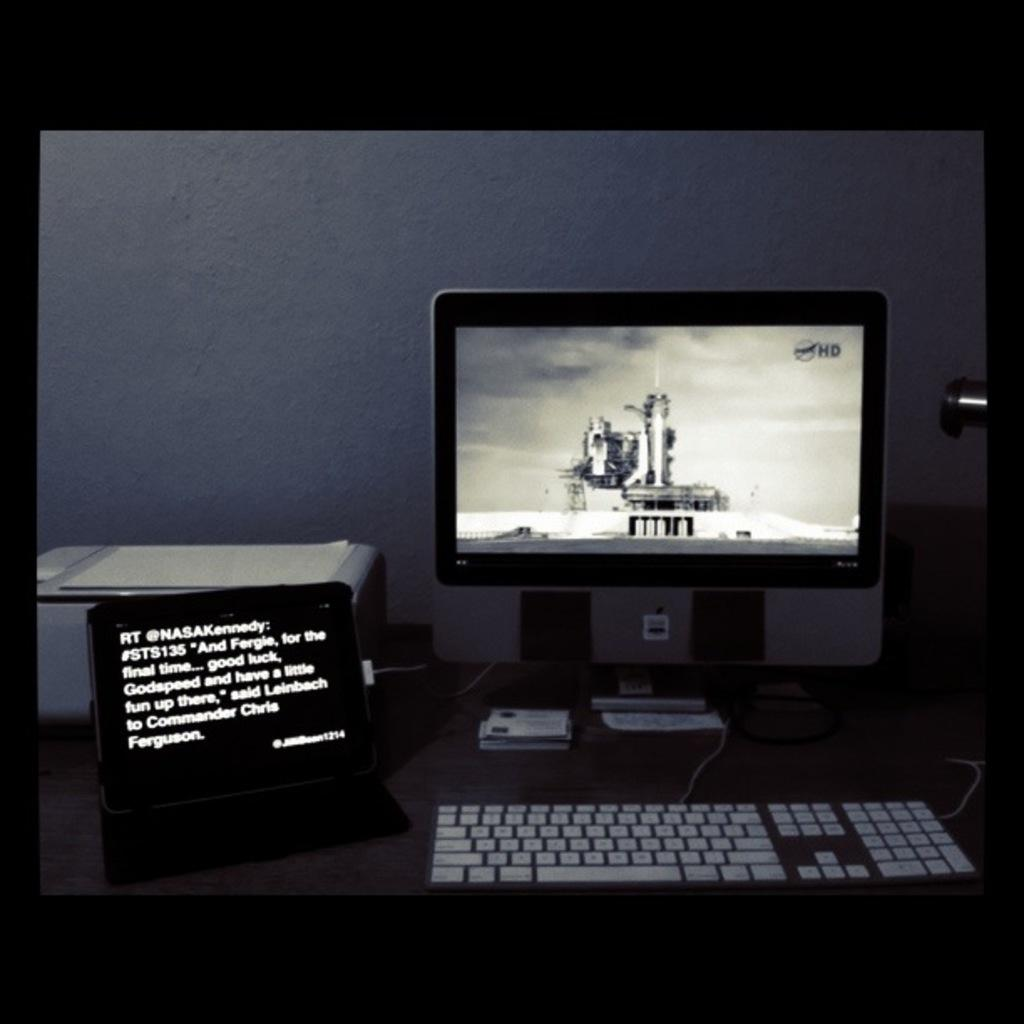<image>
Relay a brief, clear account of the picture shown. The computer monitor screen has HD in the upper right corner. 